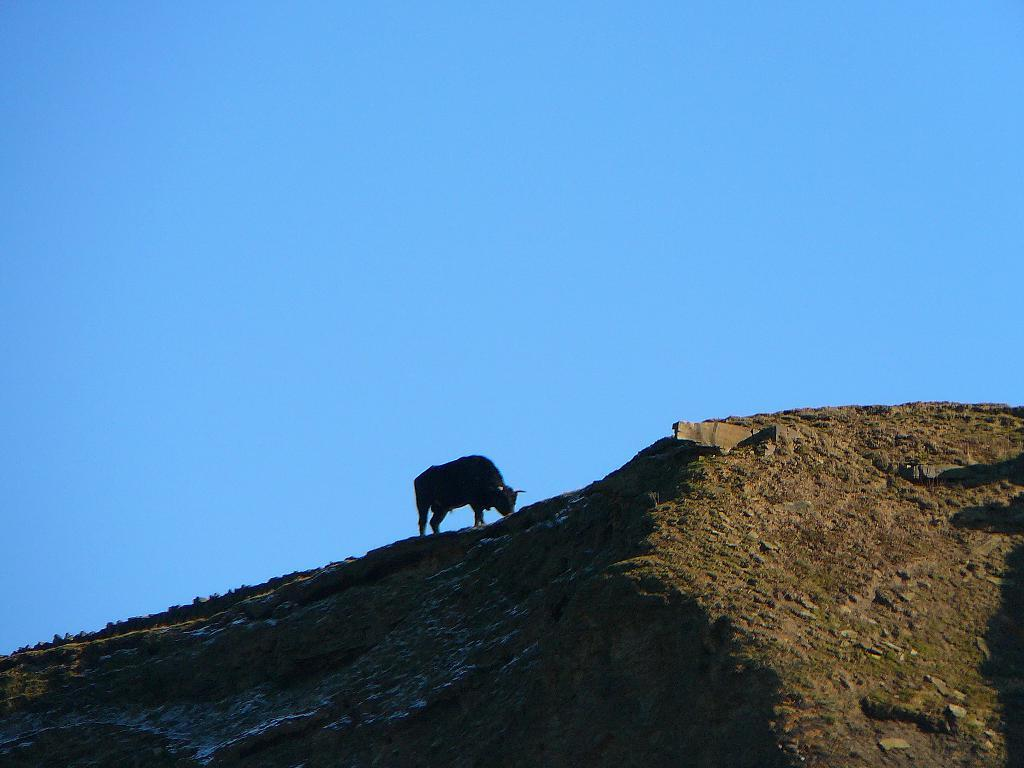What type of terrain is visible in the image? There is a hill with grass in the image. Is there any living creature on the hill? Yes, there is an animal on the hill. What can be seen at the top of the image? The sky is visible at the top of the image. What type of credit card is being used by the animal on the hill in the image? There is no credit card or any indication of a financial transaction in the image; it features a hill with grass and an animal. 